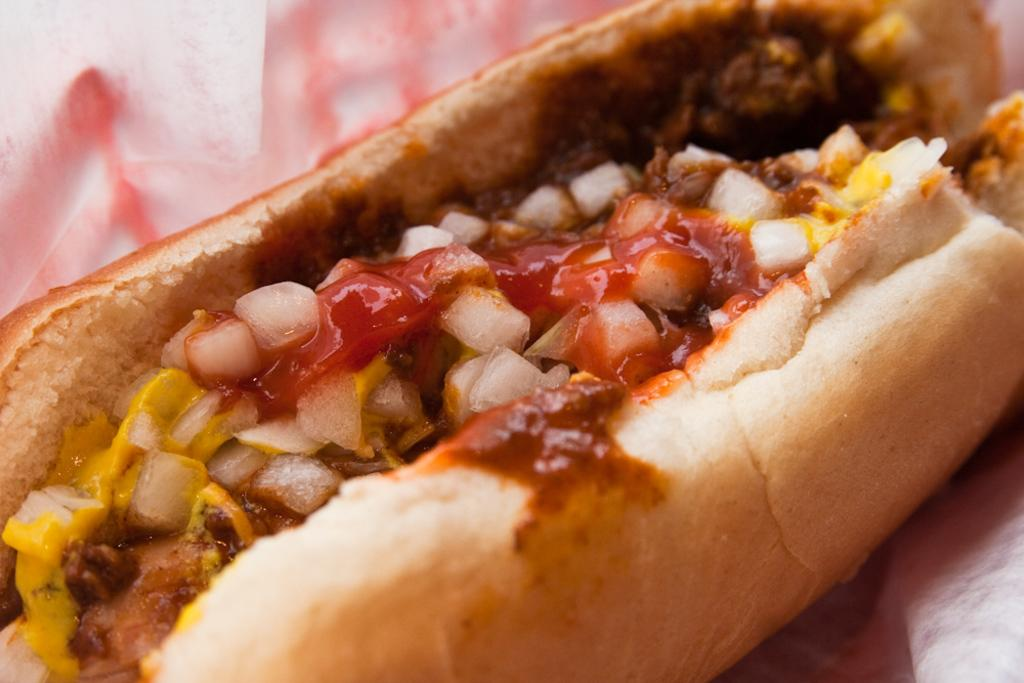What type of food is visible in the image? There is food in the image, specifically a bun with a sauce on it. What specific ingredient can be seen in the image? There are onions in the image. What is the sauce on the bun? The sauce on the bun is not specified in the facts provided. How many beggars can be seen in the image? There are no beggars present in the image. What color are the eyes of the person in the image? There is no person present in the image, so their eye color cannot be determined. 